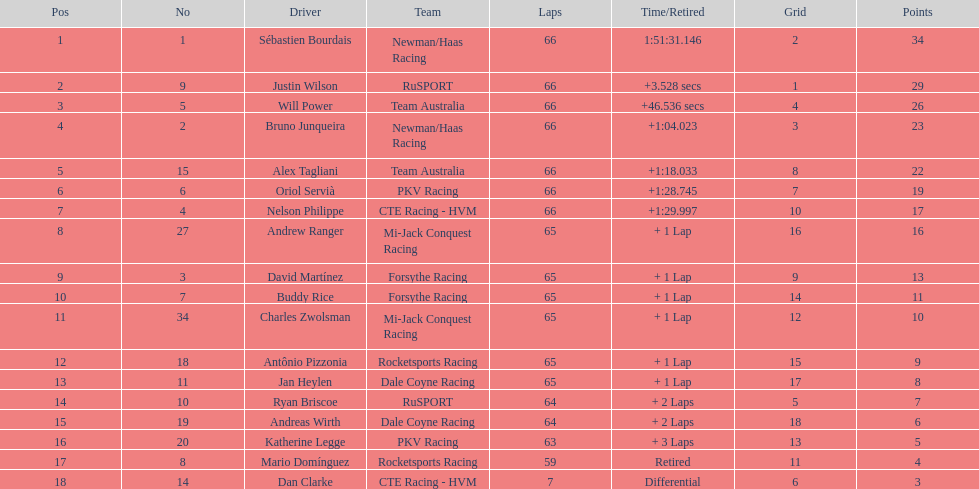Which country had more drivers representing them, the us or germany? Tie. 